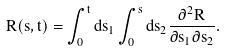Convert formula to latex. <formula><loc_0><loc_0><loc_500><loc_500>R ( s , t ) = \int _ { 0 } ^ { t } d s _ { 1 } \int _ { 0 } ^ { s } d s _ { 2 } \frac { \partial ^ { 2 } R } { \partial s _ { 1 } \partial s _ { 2 } } .</formula> 